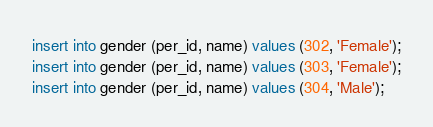Convert code to text. <code><loc_0><loc_0><loc_500><loc_500><_SQL_>insert into gender (per_id, name) values (302, 'Female');
insert into gender (per_id, name) values (303, 'Female');
insert into gender (per_id, name) values (304, 'Male');</code> 